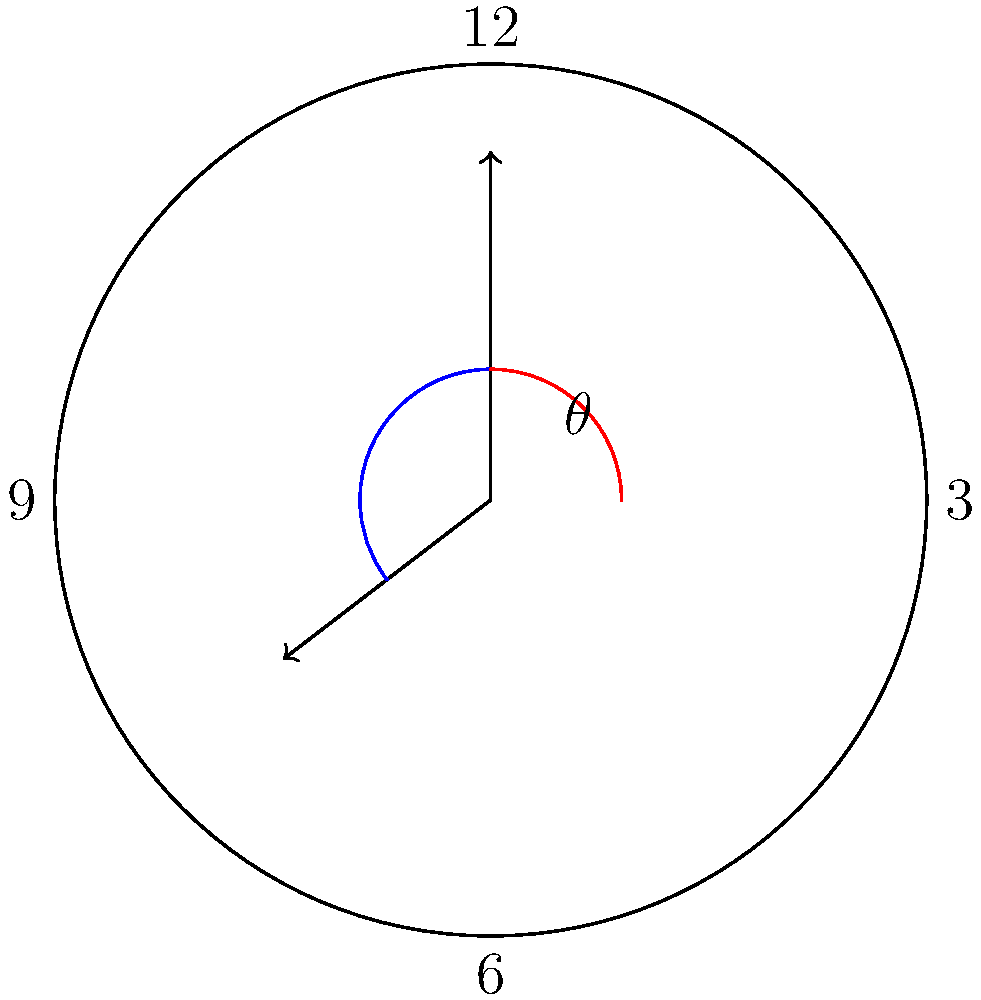Your dinner party is scheduled to start at 7:15 PM. As you're setting the table, you notice the interesting angle formed by the clock hands. What is the measure of the acute angle $\theta$ (in degrees) between the hour and minute hands at this time? Let's solve this step-by-step:

1) First, we need to calculate the angle for each hand:

   Hour hand: 
   - It moves 360° in 12 hours, so 30° per hour.
   - In 7 hours, it moves 7 * 30° = 210°
   - In 15 minutes, it moves an additional 15/60 * 30° = 7.5°
   - Total for hour hand: 210° + 7.5° = 217.5°

   Minute hand:
   - It moves 360° in 60 minutes, so 6° per minute.
   - In 15 minutes, it moves 15 * 6° = 90°

2) The angle between the hands is the absolute difference:
   $|217.5° - 90°| = 127.5°$

3) However, we need the acute angle. If the angle is greater than 180°, we subtract it from 360°:
   $360° - 127.5° = 232.5°$

4) The acute angle is the smaller of these two:
   $\min(127.5°, 232.5°) = 127.5°$

Therefore, the acute angle between the hour and minute hands at 7:15 PM is 127.5°.
Answer: 127.5° 